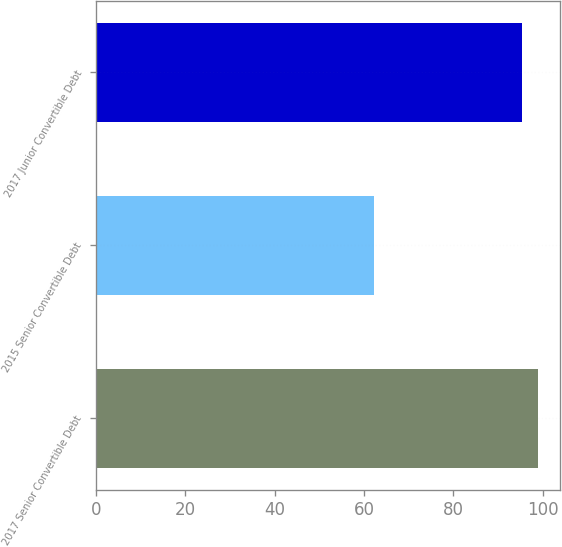<chart> <loc_0><loc_0><loc_500><loc_500><bar_chart><fcel>2017 Senior Convertible Debt<fcel>2015 Senior Convertible Debt<fcel>2017 Junior Convertible Debt<nl><fcel>98.94<fcel>62.3<fcel>95.45<nl></chart> 